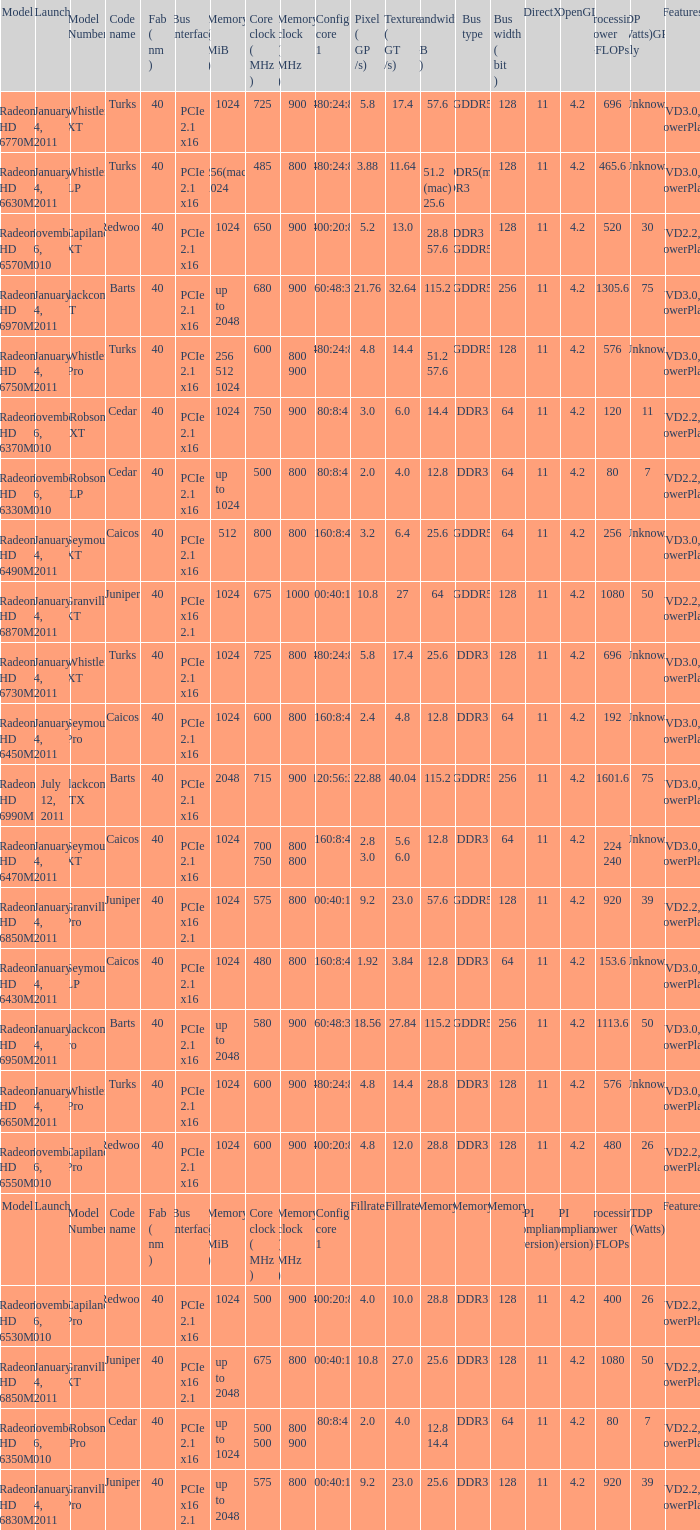How many values for bus width have a bandwidth of 25.6 and model number of Granville Pro? 1.0. 